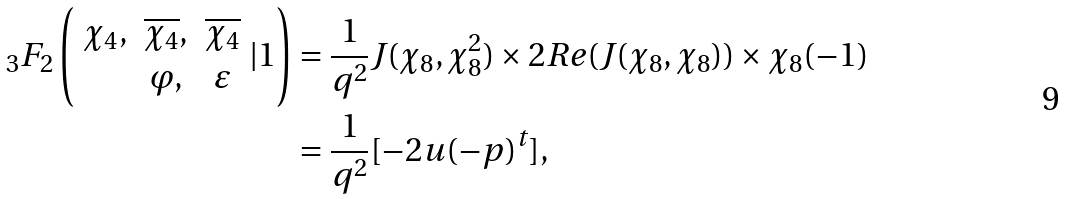Convert formula to latex. <formula><loc_0><loc_0><loc_500><loc_500>{ _ { 3 } } F _ { 2 } \left ( \begin{array} { c c c } \chi _ { 4 } , & \overline { \chi _ { 4 } } , & \overline { \chi _ { 4 } } \\ & \varphi , & \varepsilon \end{array} | 1 \right ) & = \frac { 1 } { q ^ { 2 } } J ( \chi _ { 8 } , \chi _ { 8 } ^ { 2 } ) \times 2 R e ( J ( \chi _ { 8 } , \chi _ { 8 } ) ) \times \chi _ { 8 } ( - 1 ) \\ & = \frac { 1 } { q ^ { 2 } } [ - 2 u ( - p ) ^ { t } ] ,</formula> 